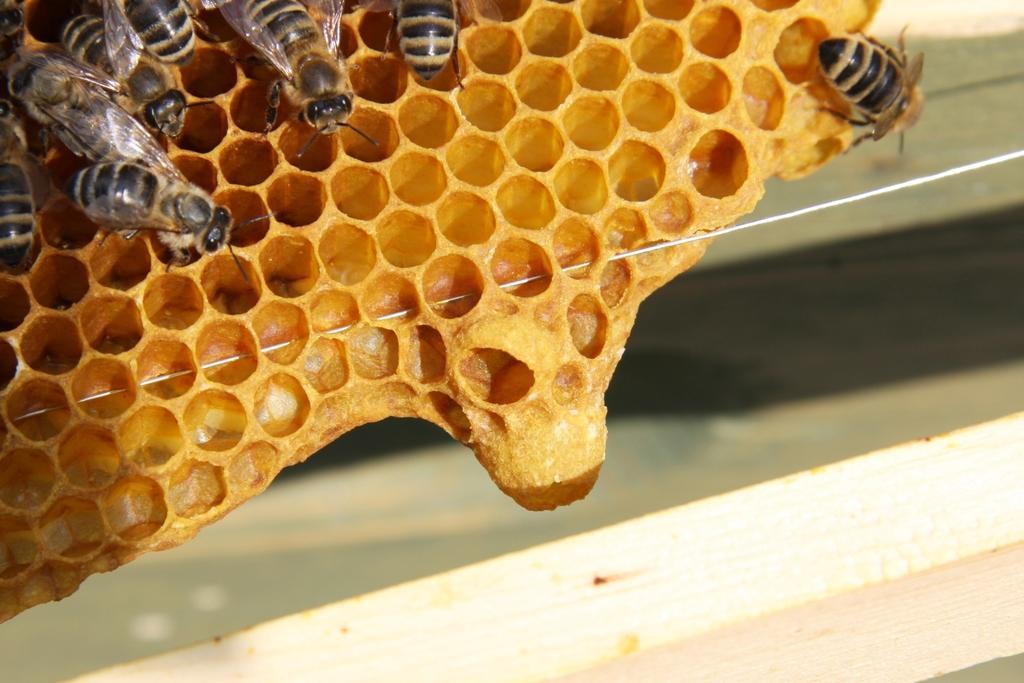Can you describe this image briefly? In the image we can see a honeycomb and honey bees. 